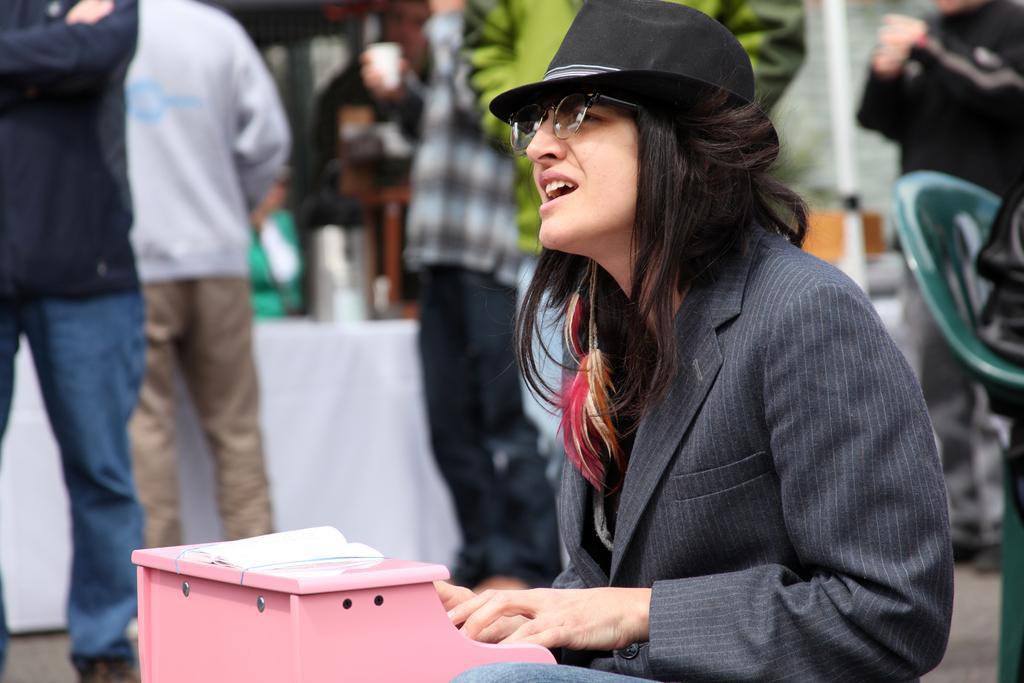How would you summarize this image in a sentence or two? Here in this picture we can see a woman sitting on a chair and we can see she is wearing a coat, spectacles and hat on her and singing and playing a musical instrument present in front of her and behind her also we can see number of people standing over there. 